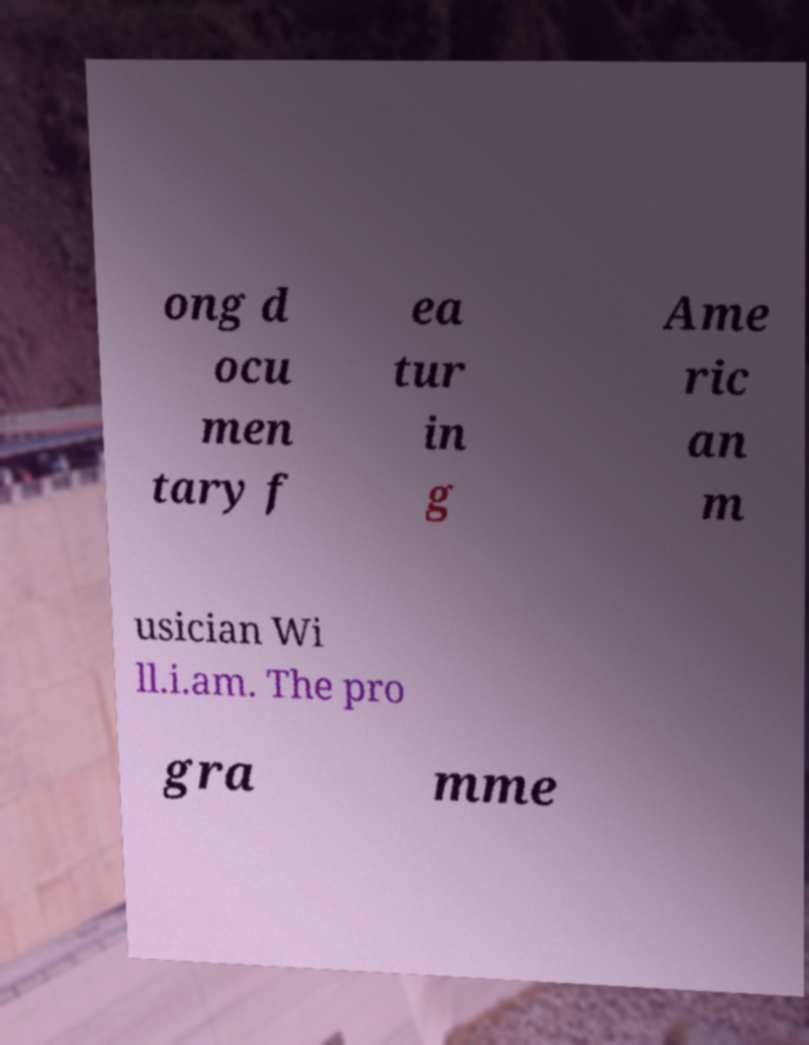There's text embedded in this image that I need extracted. Can you transcribe it verbatim? ong d ocu men tary f ea tur in g Ame ric an m usician Wi ll.i.am. The pro gra mme 